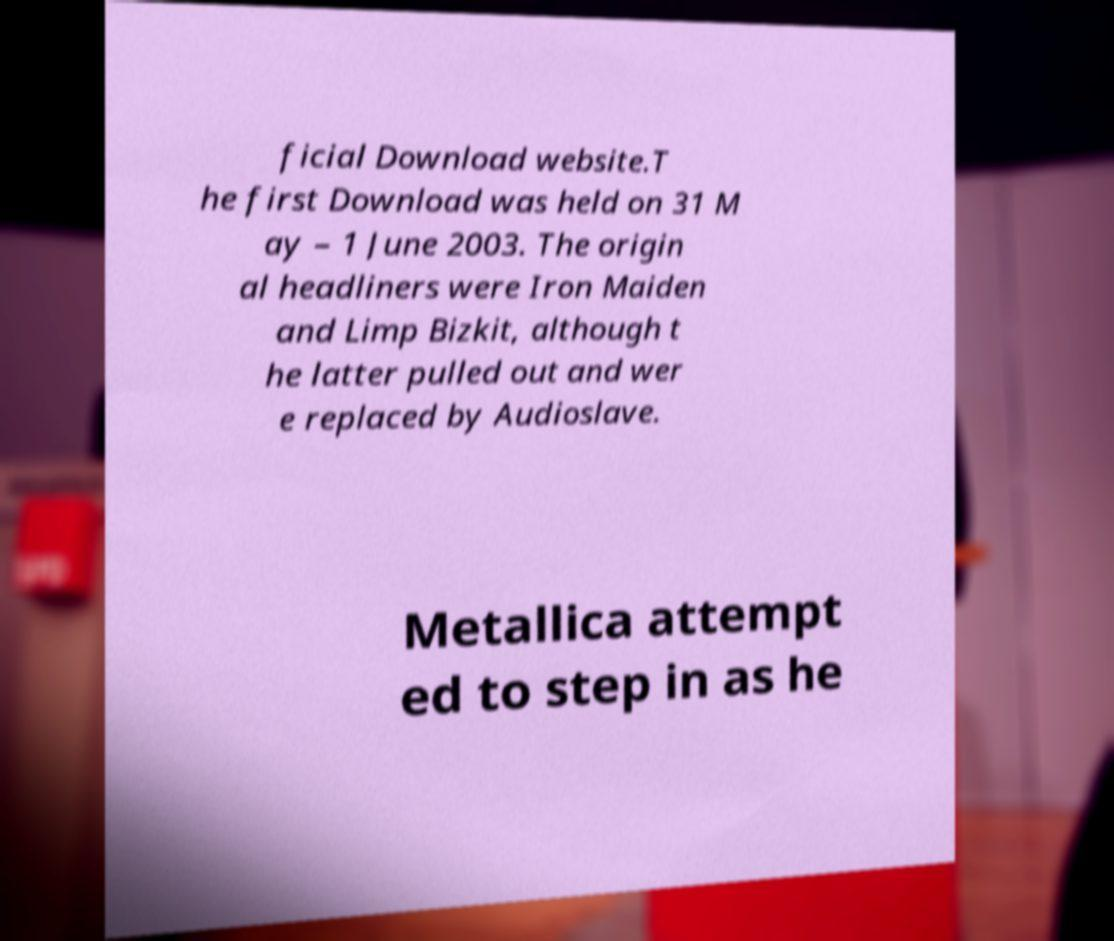Can you accurately transcribe the text from the provided image for me? ficial Download website.T he first Download was held on 31 M ay – 1 June 2003. The origin al headliners were Iron Maiden and Limp Bizkit, although t he latter pulled out and wer e replaced by Audioslave. Metallica attempt ed to step in as he 